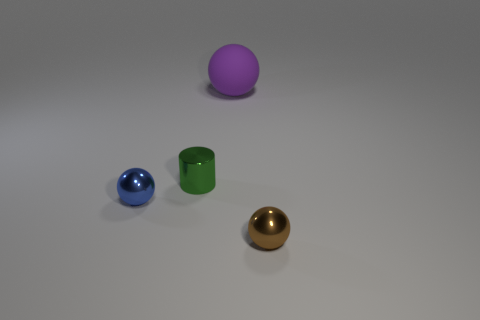Subtract all brown metal balls. How many balls are left? 2 Add 1 tiny cyan metallic cubes. How many objects exist? 5 Subtract all spheres. How many objects are left? 1 Subtract all yellow spheres. Subtract all brown cylinders. How many spheres are left? 3 Add 1 large rubber things. How many large rubber things are left? 2 Add 1 small brown cylinders. How many small brown cylinders exist? 1 Subtract 0 cyan blocks. How many objects are left? 4 Subtract all metallic objects. Subtract all blue objects. How many objects are left? 0 